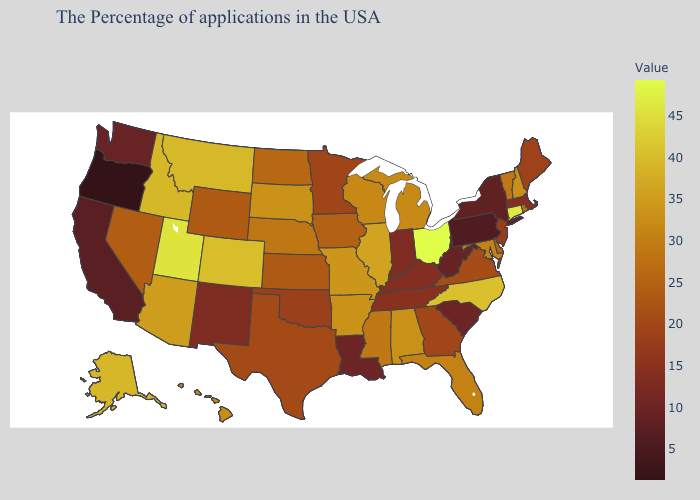Among the states that border Connecticut , which have the highest value?
Write a very short answer. Rhode Island. Does Idaho have a higher value than Maryland?
Give a very brief answer. Yes. Which states have the lowest value in the USA?
Give a very brief answer. Oregon. Among the states that border Arizona , does Utah have the lowest value?
Answer briefly. No. Among the states that border Michigan , which have the highest value?
Short answer required. Ohio. Is the legend a continuous bar?
Write a very short answer. Yes. Among the states that border Louisiana , which have the lowest value?
Keep it brief. Texas. Which states hav the highest value in the South?
Concise answer only. North Carolina. 